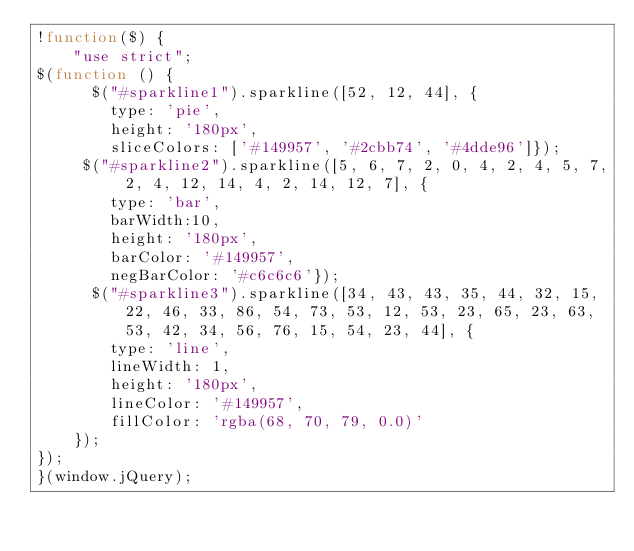Convert code to text. <code><loc_0><loc_0><loc_500><loc_500><_JavaScript_>!function($) {
    "use strict";
$(function () {
      $("#sparkline1").sparkline([52, 12, 44], {
        type: 'pie',
        height: '180px',
        sliceColors: ['#149957', '#2cbb74', '#4dde96']});
     $("#sparkline2").sparkline([5, 6, 7, 2, 0, 4, 2, 4, 5, 7, 2, 4, 12, 14, 4, 2, 14, 12, 7], {
        type: 'bar',
        barWidth:10,
        height: '180px',
        barColor: '#149957',
        negBarColor: '#c6c6c6'});
      $("#sparkline3").sparkline([34, 43, 43, 35, 44, 32, 15, 22, 46, 33, 86, 54, 73, 53, 12, 53, 23, 65, 23, 63, 53, 42, 34, 56, 76, 15, 54, 23, 44], {
        type: 'line',
        lineWidth: 1,
        height: '180px',
        lineColor: '#149957',
        fillColor: 'rgba(68, 70, 79, 0.0)'
    });
});
}(window.jQuery);
</code> 